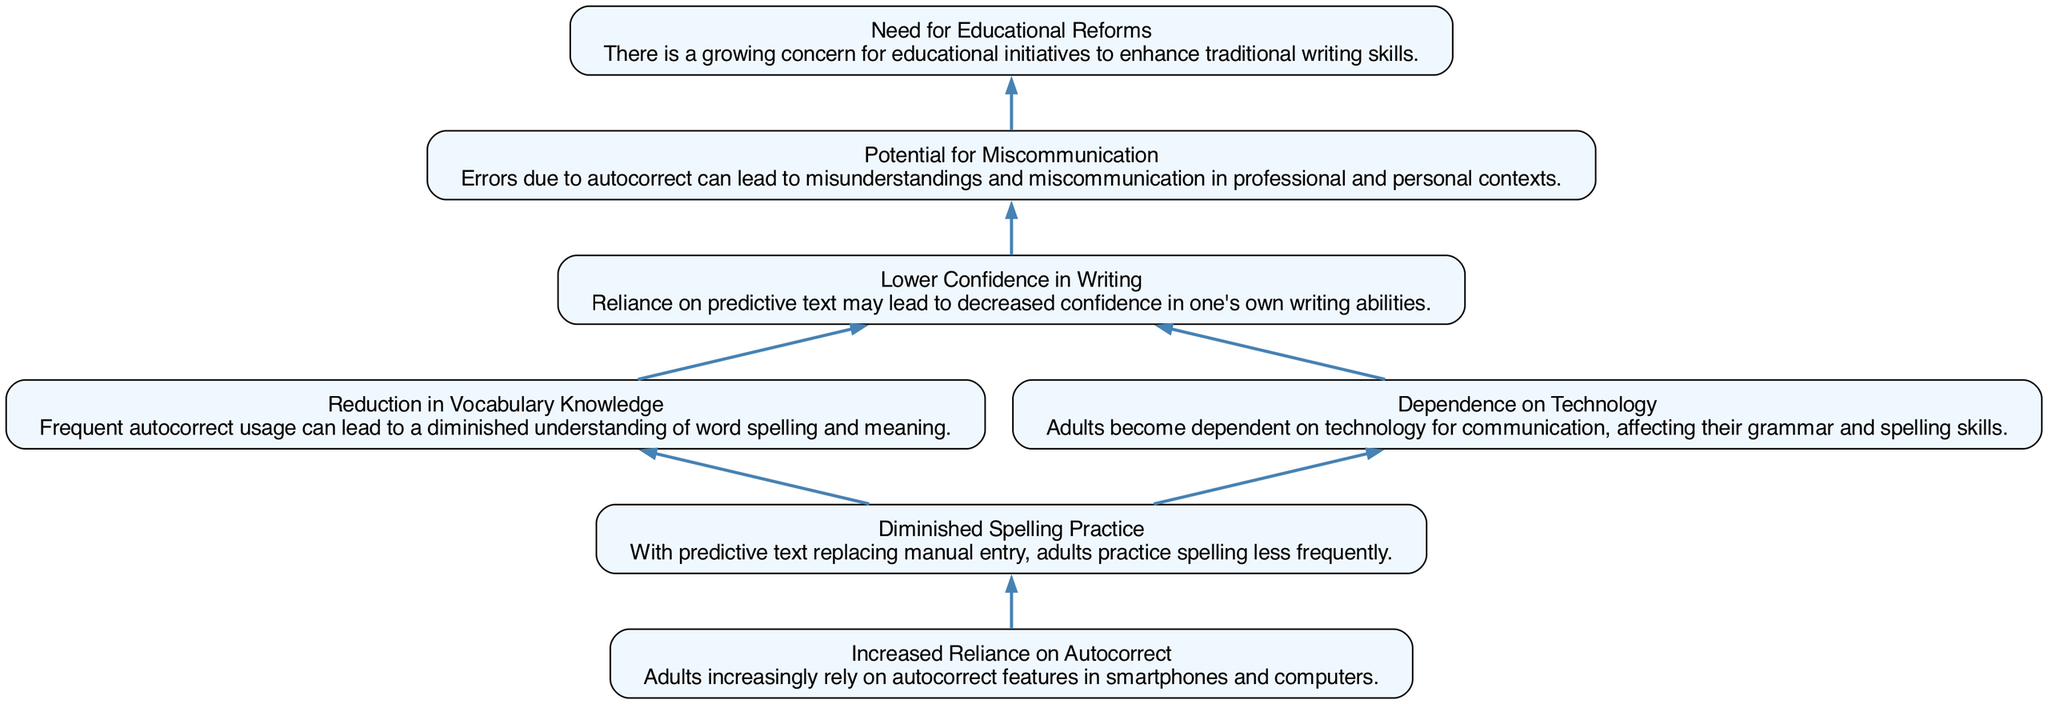What is the first node in the diagram? The first node in the diagram is "Increased Reliance on Autocorrect." By looking at the bottom of the flow chart, we see that this is the starting point, representing the initial condition influencing other factors.
Answer: Increased Reliance on Autocorrect How many nodes are in the diagram? By counting each of the labeled boxes in the flow chart, we identify that there are a total of seven nodes present.
Answer: 7 What is the last node in the diagram? The last node in the diagram is "Need for Educational Reforms." This node is at the top, indicating the ultimate consequence or outcome of the previous elements.
Answer: Need for Educational Reforms Which two nodes are directly connected? The nodes "Diminished Spelling Practice" and "Reduction in Vocabulary Knowledge" are directly connected. This can be seen by the edge indicating that one influences the other in the flow of information.
Answer: Diminished Spelling Practice and Reduction in Vocabulary Knowledge Which node does "Dependence on Technology" lead to? "Dependence on Technology" leads to the node "Lower Confidence in Writing." This shows a flow where reliance on technology impacts self-esteem in writing.
Answer: Lower Confidence in Writing How does "Increased Reliance on Autocorrect" affect "Dependence on Technology"? "Increased Reliance on Autocorrect" leads to "Dependence on Technology." This indicates that relying heavily on autocorrect tools results in a greater dependence on technology for communication.
Answer: Dependence on Technology What is the connection between "Lower Confidence in Writing" and "Potential for Miscommunication"? "Lower Confidence in Writing" leads to "Potential for Miscommunication." This shows that when individuals are less confident in their writing, it increases the chances of misunderstandings.
Answer: Potential for Miscommunication What does the diagram imply about spelling practice and vocabulary knowledge? The diagram implies that "Diminished Spelling Practice" leads to "Reduction in Vocabulary Knowledge." This indicates that less practice in spelling negatively affects a person's vocabulary understanding.
Answer: Reduction in Vocabulary Knowledge 